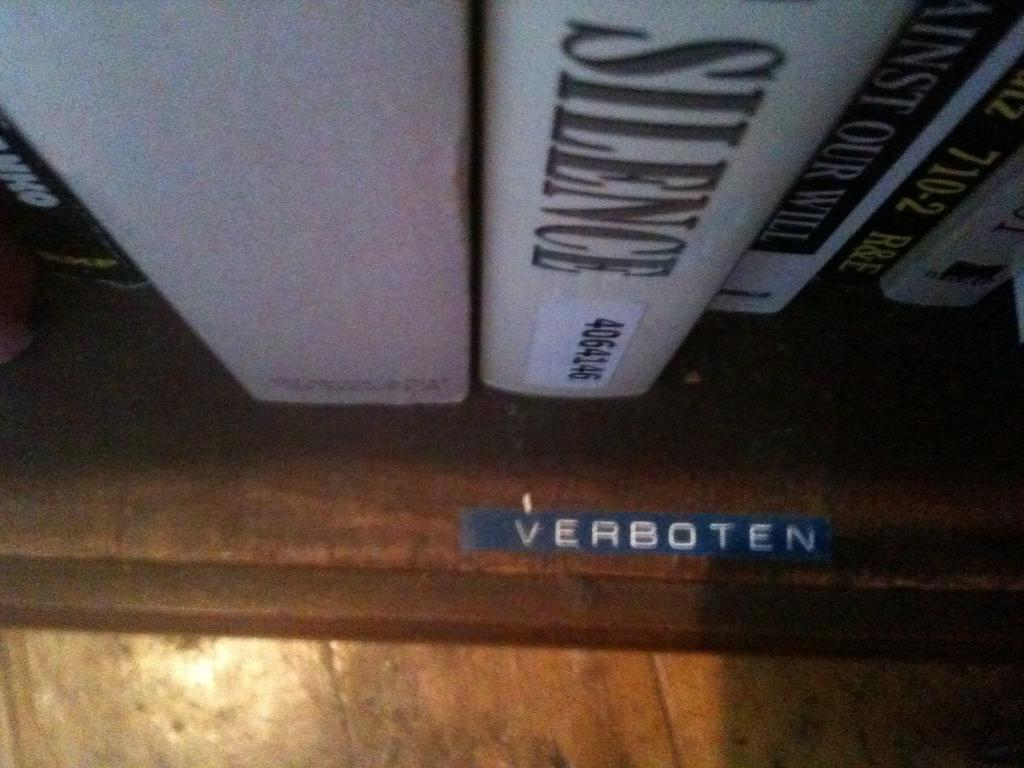<image>
Write a terse but informative summary of the picture. A brown shelf containing books is labeled Verboten. 